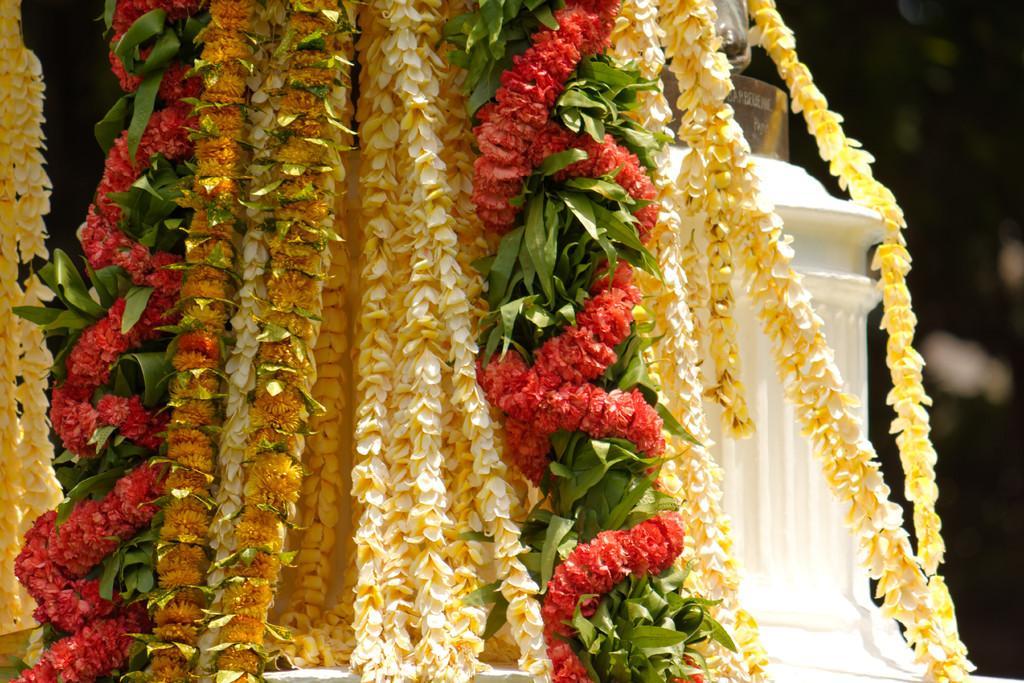Describe this image in one or two sentences. In this picture we can see some colorful garlands and a white object on the right side. 